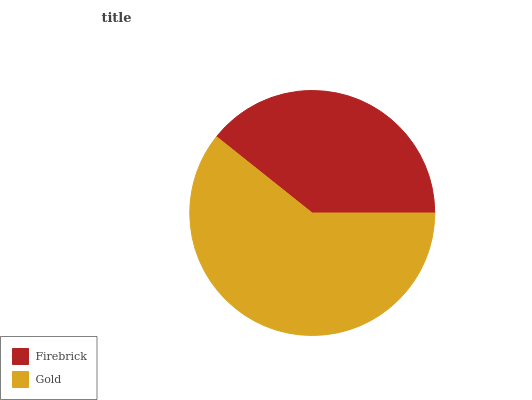Is Firebrick the minimum?
Answer yes or no. Yes. Is Gold the maximum?
Answer yes or no. Yes. Is Gold the minimum?
Answer yes or no. No. Is Gold greater than Firebrick?
Answer yes or no. Yes. Is Firebrick less than Gold?
Answer yes or no. Yes. Is Firebrick greater than Gold?
Answer yes or no. No. Is Gold less than Firebrick?
Answer yes or no. No. Is Gold the high median?
Answer yes or no. Yes. Is Firebrick the low median?
Answer yes or no. Yes. Is Firebrick the high median?
Answer yes or no. No. Is Gold the low median?
Answer yes or no. No. 